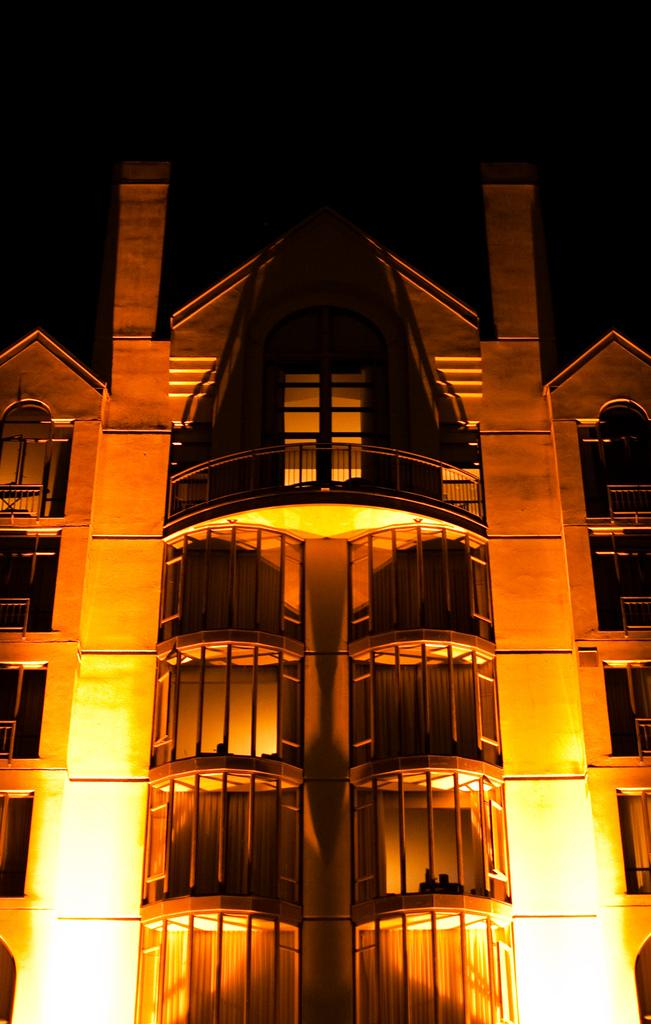What type of structure is present in the image? There is a building in the image. What can be seen near the building? There are grills and railings visible in the image. What type of lighting is present in the image? Electric lights are visible in the image. What part of the natural environment is visible in the image? The sky is visible in the image. What type of seed is being planted in the image? There is no seed or planting activity present in the image. Can you see a train passing by in the image? There is no train visible in the image. 